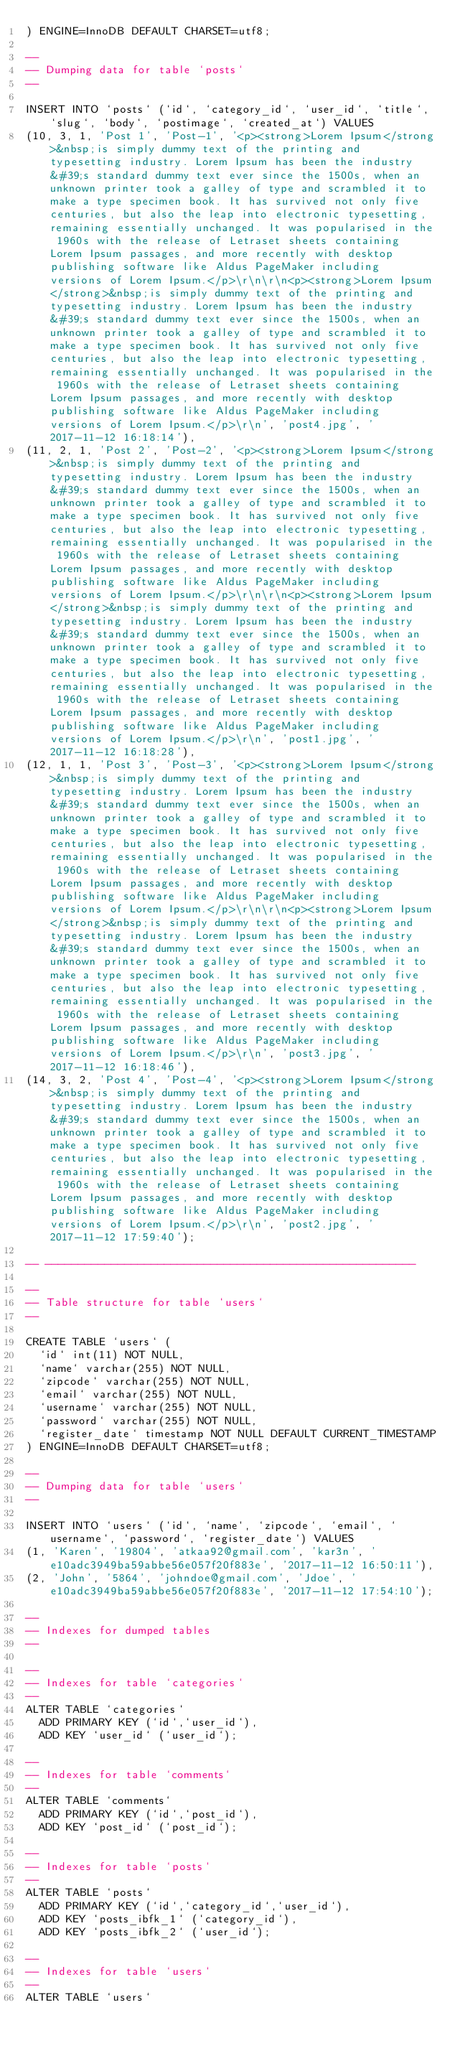Convert code to text. <code><loc_0><loc_0><loc_500><loc_500><_SQL_>) ENGINE=InnoDB DEFAULT CHARSET=utf8;

--
-- Dumping data for table `posts`
--

INSERT INTO `posts` (`id`, `category_id`, `user_id`, `title`, `slug`, `body`, `postimage`, `created_at`) VALUES
(10, 3, 1, 'Post 1', 'Post-1', '<p><strong>Lorem Ipsum</strong>&nbsp;is simply dummy text of the printing and typesetting industry. Lorem Ipsum has been the industry&#39;s standard dummy text ever since the 1500s, when an unknown printer took a galley of type and scrambled it to make a type specimen book. It has survived not only five centuries, but also the leap into electronic typesetting, remaining essentially unchanged. It was popularised in the 1960s with the release of Letraset sheets containing Lorem Ipsum passages, and more recently with desktop publishing software like Aldus PageMaker including versions of Lorem Ipsum.</p>\r\n\r\n<p><strong>Lorem Ipsum</strong>&nbsp;is simply dummy text of the printing and typesetting industry. Lorem Ipsum has been the industry&#39;s standard dummy text ever since the 1500s, when an unknown printer took a galley of type and scrambled it to make a type specimen book. It has survived not only five centuries, but also the leap into electronic typesetting, remaining essentially unchanged. It was popularised in the 1960s with the release of Letraset sheets containing Lorem Ipsum passages, and more recently with desktop publishing software like Aldus PageMaker including versions of Lorem Ipsum.</p>\r\n', 'post4.jpg', '2017-11-12 16:18:14'),
(11, 2, 1, 'Post 2', 'Post-2', '<p><strong>Lorem Ipsum</strong>&nbsp;is simply dummy text of the printing and typesetting industry. Lorem Ipsum has been the industry&#39;s standard dummy text ever since the 1500s, when an unknown printer took a galley of type and scrambled it to make a type specimen book. It has survived not only five centuries, but also the leap into electronic typesetting, remaining essentially unchanged. It was popularised in the 1960s with the release of Letraset sheets containing Lorem Ipsum passages, and more recently with desktop publishing software like Aldus PageMaker including versions of Lorem Ipsum.</p>\r\n\r\n<p><strong>Lorem Ipsum</strong>&nbsp;is simply dummy text of the printing and typesetting industry. Lorem Ipsum has been the industry&#39;s standard dummy text ever since the 1500s, when an unknown printer took a galley of type and scrambled it to make a type specimen book. It has survived not only five centuries, but also the leap into electronic typesetting, remaining essentially unchanged. It was popularised in the 1960s with the release of Letraset sheets containing Lorem Ipsum passages, and more recently with desktop publishing software like Aldus PageMaker including versions of Lorem Ipsum.</p>\r\n', 'post1.jpg', '2017-11-12 16:18:28'),
(12, 1, 1, 'Post 3', 'Post-3', '<p><strong>Lorem Ipsum</strong>&nbsp;is simply dummy text of the printing and typesetting industry. Lorem Ipsum has been the industry&#39;s standard dummy text ever since the 1500s, when an unknown printer took a galley of type and scrambled it to make a type specimen book. It has survived not only five centuries, but also the leap into electronic typesetting, remaining essentially unchanged. It was popularised in the 1960s with the release of Letraset sheets containing Lorem Ipsum passages, and more recently with desktop publishing software like Aldus PageMaker including versions of Lorem Ipsum.</p>\r\n\r\n<p><strong>Lorem Ipsum</strong>&nbsp;is simply dummy text of the printing and typesetting industry. Lorem Ipsum has been the industry&#39;s standard dummy text ever since the 1500s, when an unknown printer took a galley of type and scrambled it to make a type specimen book. It has survived not only five centuries, but also the leap into electronic typesetting, remaining essentially unchanged. It was popularised in the 1960s with the release of Letraset sheets containing Lorem Ipsum passages, and more recently with desktop publishing software like Aldus PageMaker including versions of Lorem Ipsum.</p>\r\n', 'post3.jpg', '2017-11-12 16:18:46'),
(14, 3, 2, 'Post 4', 'Post-4', '<p><strong>Lorem Ipsum</strong>&nbsp;is simply dummy text of the printing and typesetting industry. Lorem Ipsum has been the industry&#39;s standard dummy text ever since the 1500s, when an unknown printer took a galley of type and scrambled it to make a type specimen book. It has survived not only five centuries, but also the leap into electronic typesetting, remaining essentially unchanged. It was popularised in the 1960s with the release of Letraset sheets containing Lorem Ipsum passages, and more recently with desktop publishing software like Aldus PageMaker including versions of Lorem Ipsum.</p>\r\n', 'post2.jpg', '2017-11-12 17:59:40');

-- --------------------------------------------------------

--
-- Table structure for table `users`
--

CREATE TABLE `users` (
  `id` int(11) NOT NULL,
  `name` varchar(255) NOT NULL,
  `zipcode` varchar(255) NOT NULL,
  `email` varchar(255) NOT NULL,
  `username` varchar(255) NOT NULL,
  `password` varchar(255) NOT NULL,
  `register_date` timestamp NOT NULL DEFAULT CURRENT_TIMESTAMP
) ENGINE=InnoDB DEFAULT CHARSET=utf8;

--
-- Dumping data for table `users`
--

INSERT INTO `users` (`id`, `name`, `zipcode`, `email`, `username`, `password`, `register_date`) VALUES
(1, 'Karen', '19804', 'atkaa92@gmail.com', 'kar3n', 'e10adc3949ba59abbe56e057f20f883e', '2017-11-12 16:50:11'),
(2, 'John', '5864', 'johndoe@gmail.com', 'Jdoe', 'e10adc3949ba59abbe56e057f20f883e', '2017-11-12 17:54:10');

--
-- Indexes for dumped tables
--

--
-- Indexes for table `categories`
--
ALTER TABLE `categories`
  ADD PRIMARY KEY (`id`,`user_id`),
  ADD KEY `user_id` (`user_id`);

--
-- Indexes for table `comments`
--
ALTER TABLE `comments`
  ADD PRIMARY KEY (`id`,`post_id`),
  ADD KEY `post_id` (`post_id`);

--
-- Indexes for table `posts`
--
ALTER TABLE `posts`
  ADD PRIMARY KEY (`id`,`category_id`,`user_id`),
  ADD KEY `posts_ibfk_1` (`category_id`),
  ADD KEY `posts_ibfk_2` (`user_id`);

--
-- Indexes for table `users`
--
ALTER TABLE `users`</code> 